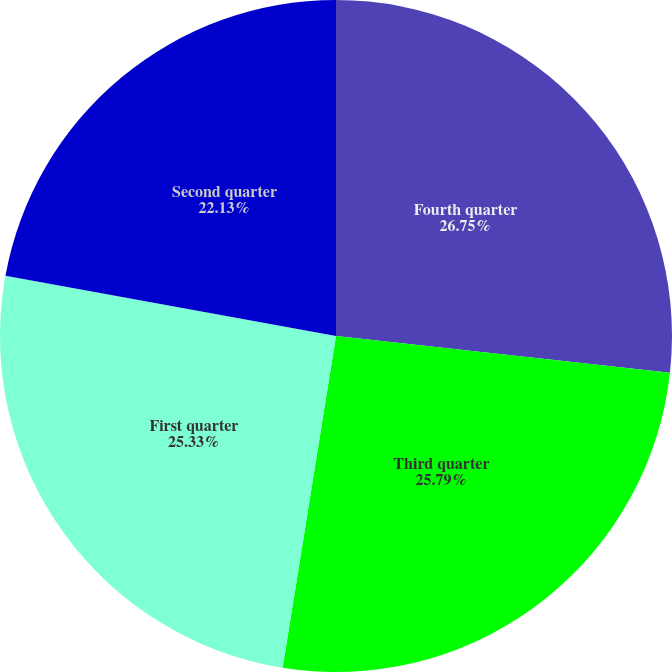Convert chart. <chart><loc_0><loc_0><loc_500><loc_500><pie_chart><fcel>Fourth quarter<fcel>Third quarter<fcel>First quarter<fcel>Second quarter<nl><fcel>26.75%<fcel>25.79%<fcel>25.33%<fcel>22.13%<nl></chart> 